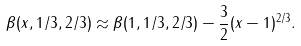<formula> <loc_0><loc_0><loc_500><loc_500>\beta ( x , 1 / 3 , 2 / 3 ) \approx \beta ( 1 , 1 / 3 , 2 / 3 ) - \frac { 3 } { 2 } ( x - 1 ) ^ { 2 / 3 } .</formula> 